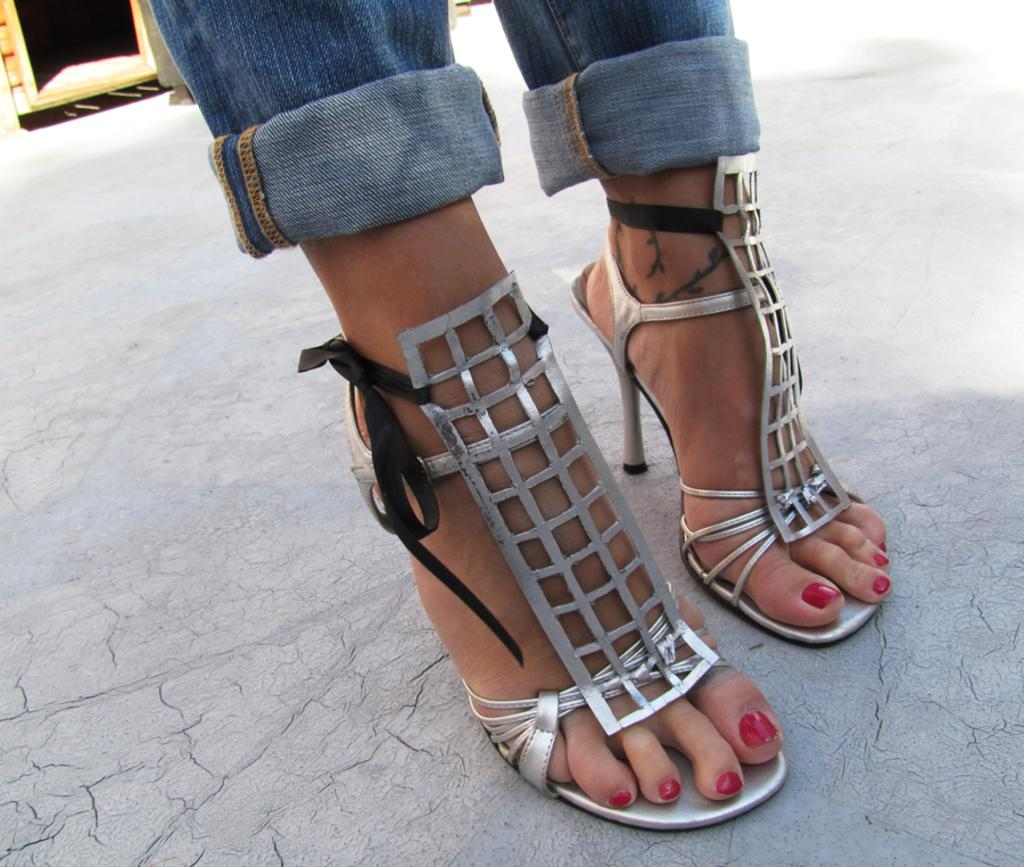What part of a person can be seen in the image? There are legs of a person in the image. What type of footwear is visible in the image? Heels are visible in the image. What type of bread is being served by the person's father in the image? There is no father or bread present in the image; it only shows legs and heels. 